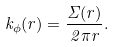<formula> <loc_0><loc_0><loc_500><loc_500>k _ { \phi } ( r ) = \frac { \Sigma ( r ) } { 2 \pi r } .</formula> 